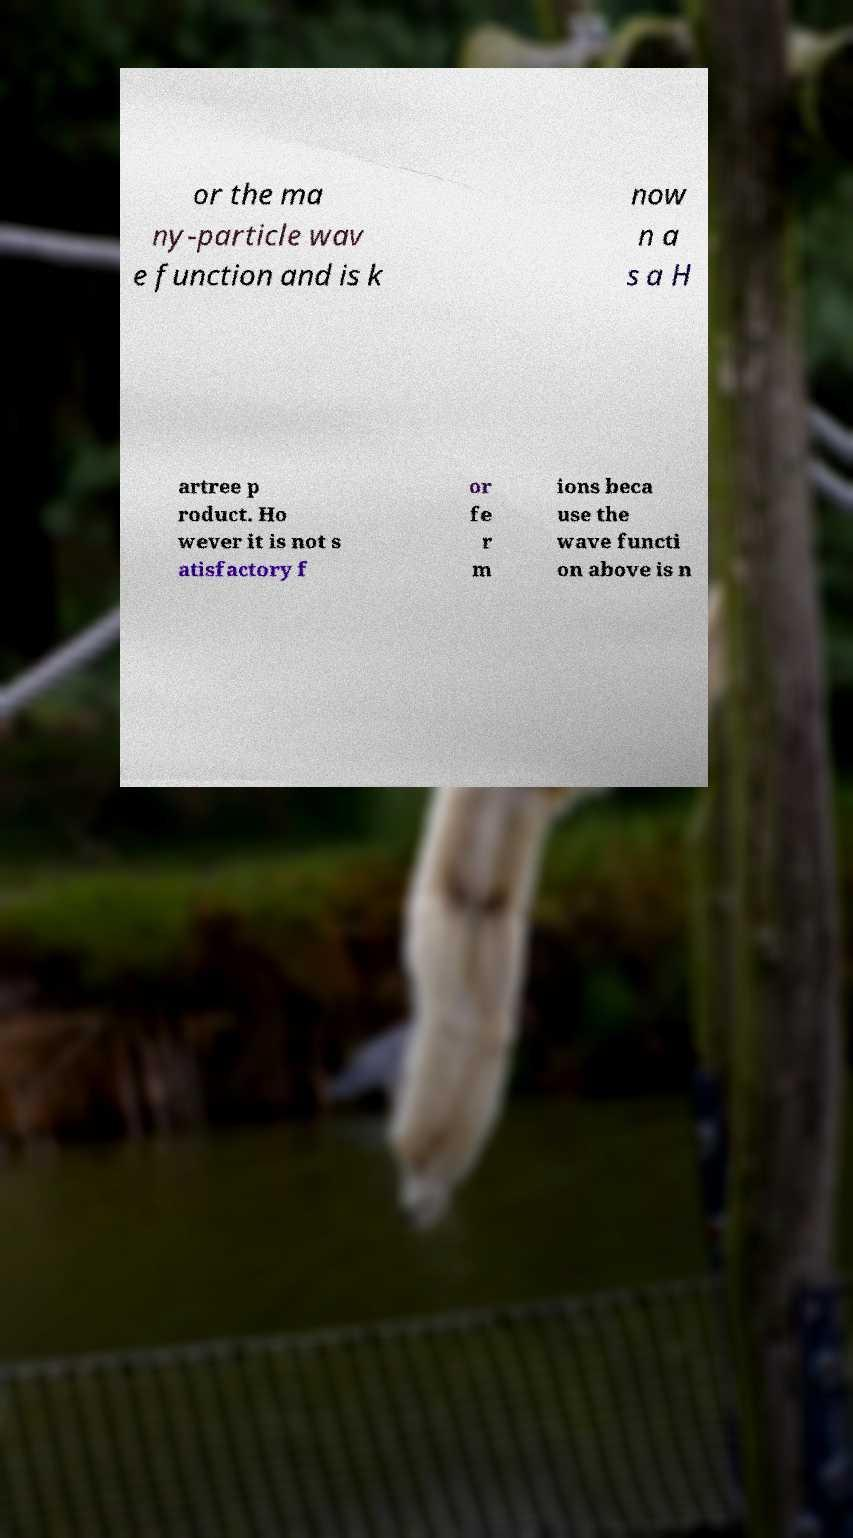Please identify and transcribe the text found in this image. or the ma ny-particle wav e function and is k now n a s a H artree p roduct. Ho wever it is not s atisfactory f or fe r m ions beca use the wave functi on above is n 